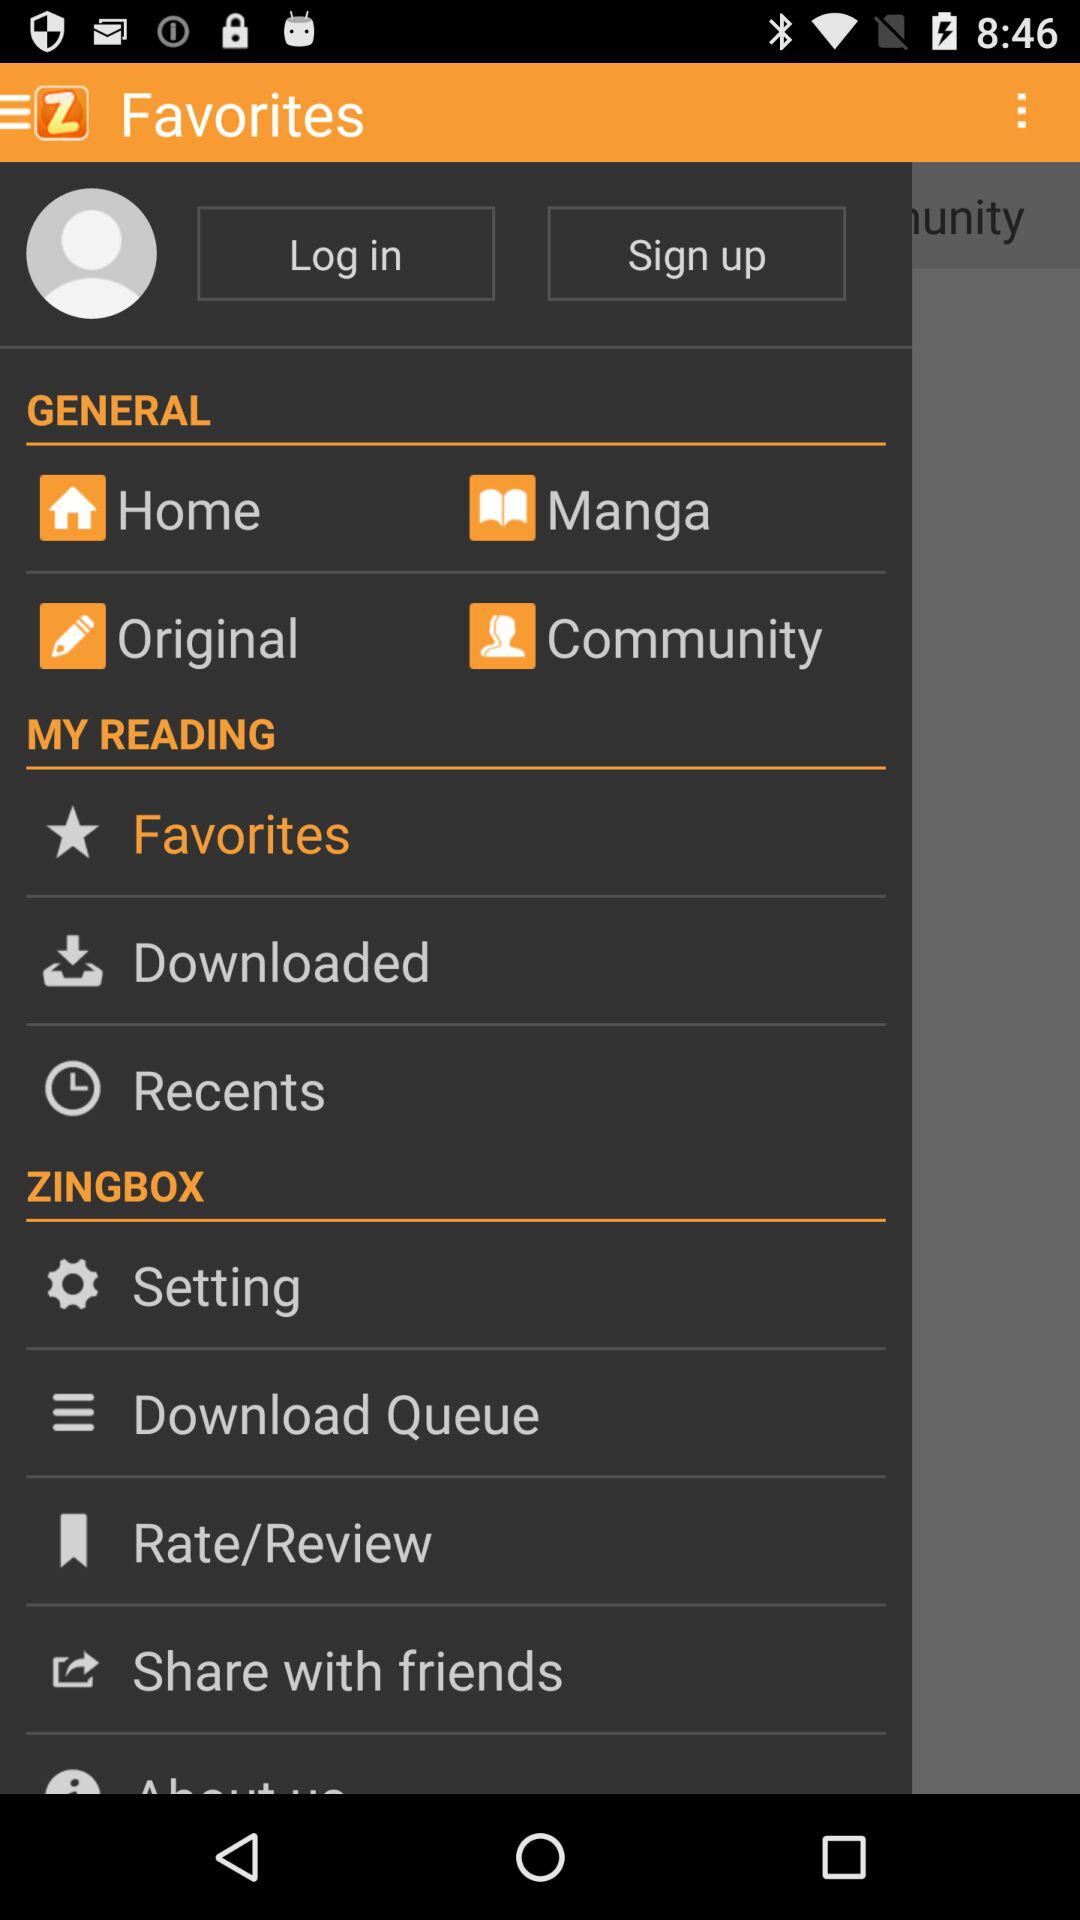What is the name of the application? The name of the application is "ZingBox Manga". 